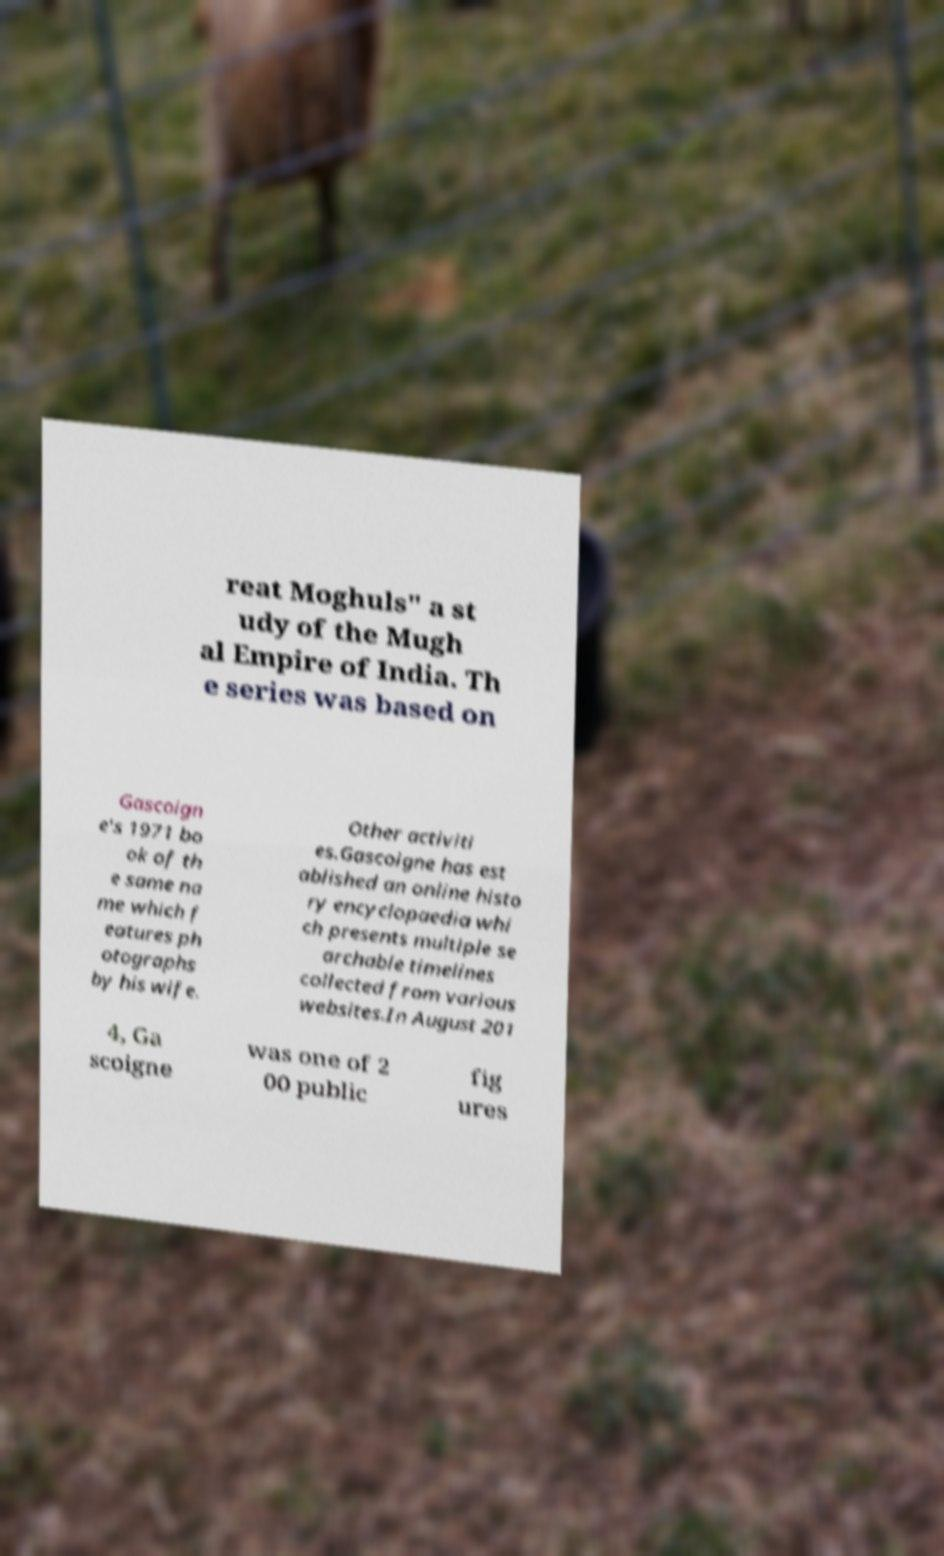Could you assist in decoding the text presented in this image and type it out clearly? reat Moghuls" a st udy of the Mugh al Empire of India. Th e series was based on Gascoign e's 1971 bo ok of th e same na me which f eatures ph otographs by his wife. Other activiti es.Gascoigne has est ablished an online histo ry encyclopaedia whi ch presents multiple se archable timelines collected from various websites.In August 201 4, Ga scoigne was one of 2 00 public fig ures 